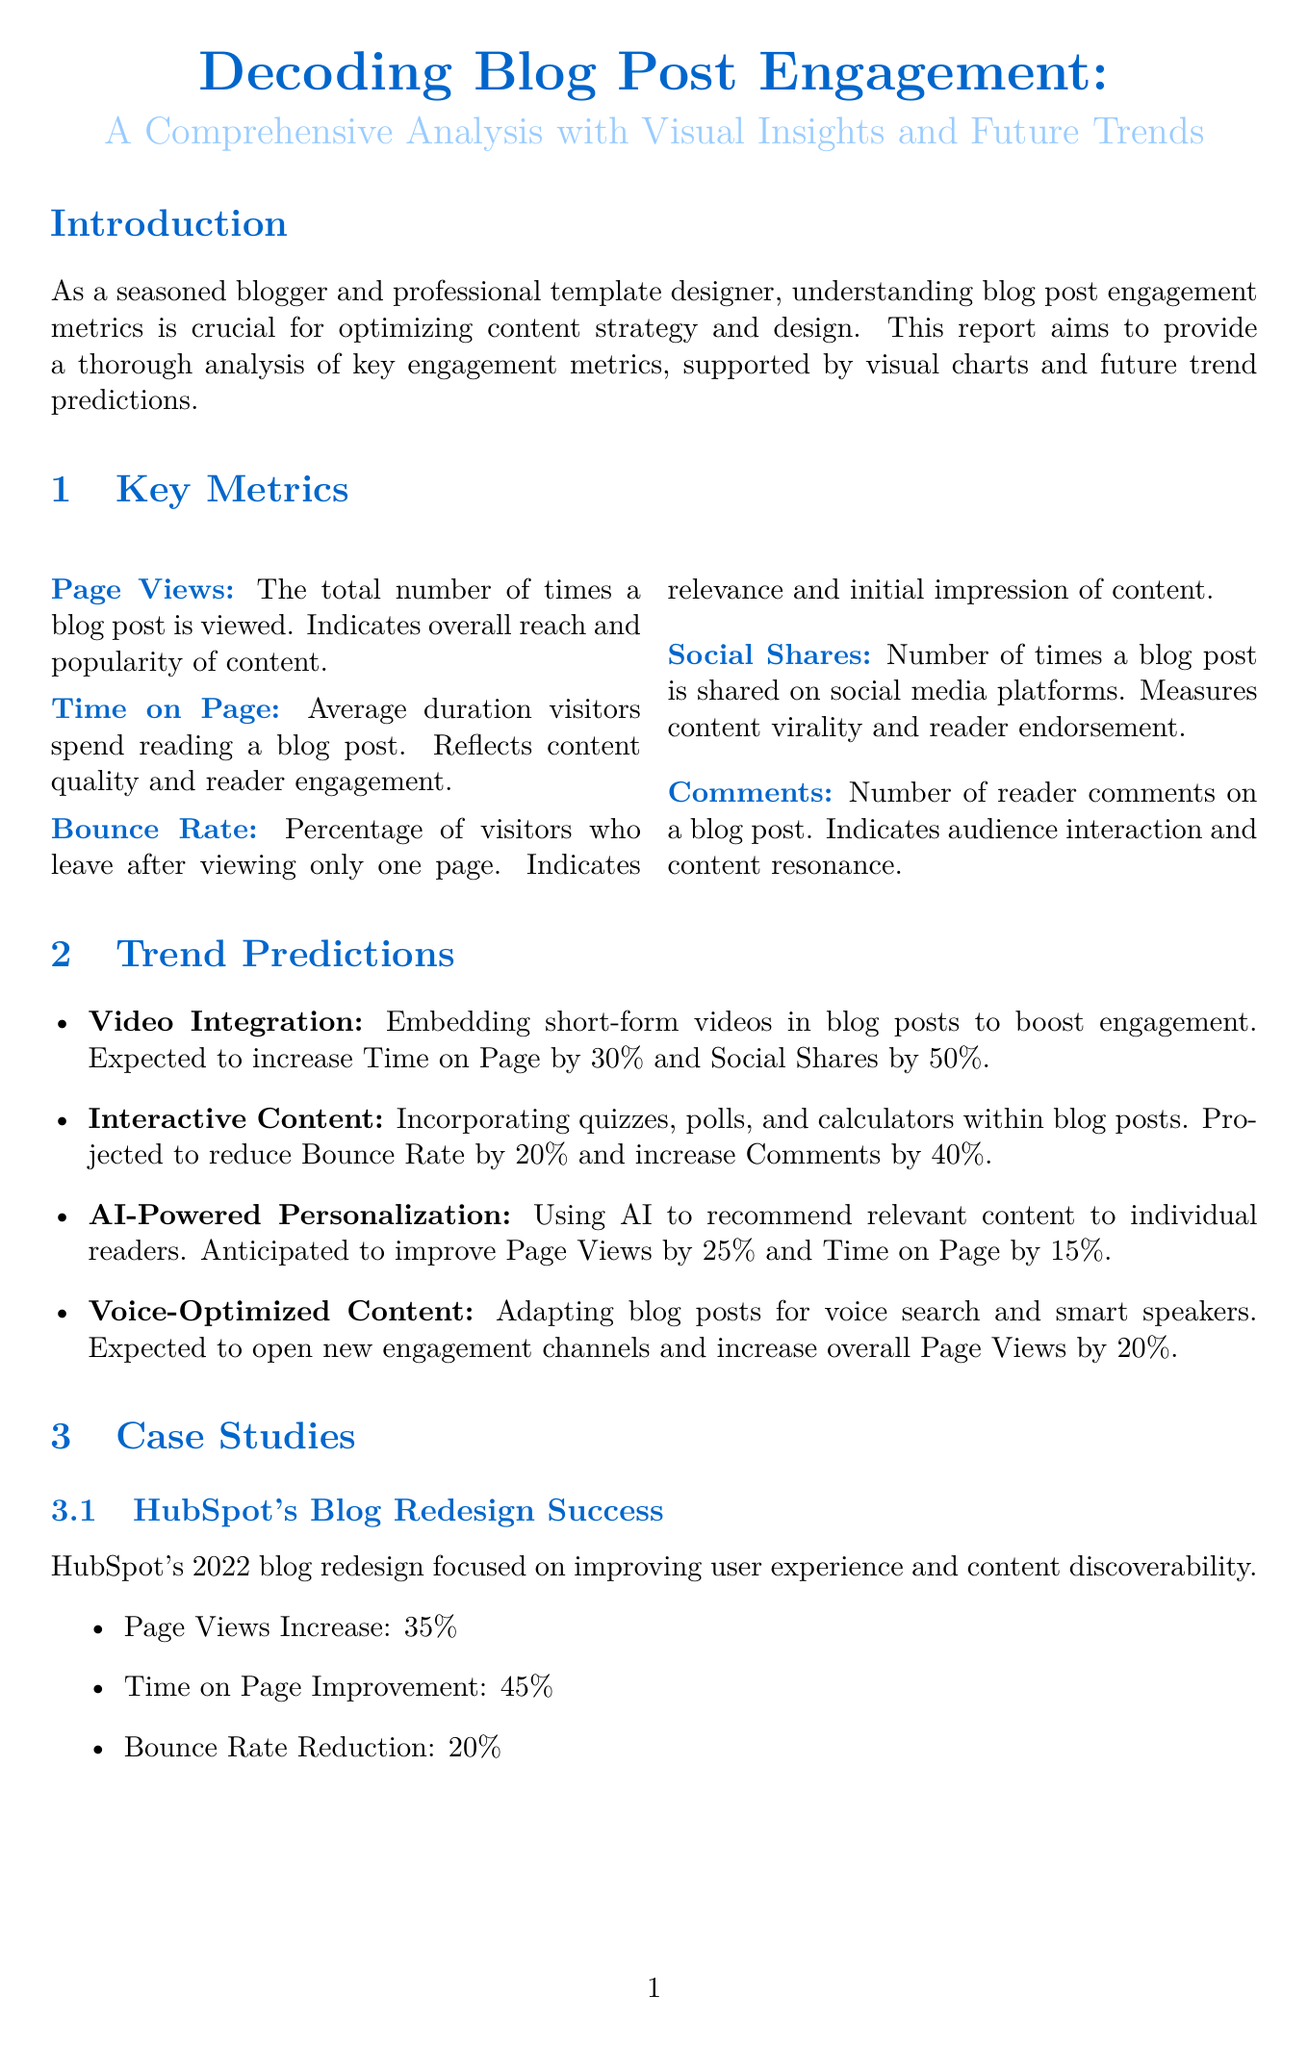What is the title of the report? The title of the report is stated at the beginning as the comprehensive analysis on blog engagement metrics.
Answer: Decoding Blog Post Engagement: A Comprehensive Analysis with Visual Insights and Future Trends How many key engagement metrics are discussed? The number of key engagement metrics is mentioned in the metrics section of the document.
Answer: Five What is the expected increase in Time on Page due to video integration? The document outlines the expected impact of video integration on Time on Page.
Answer: 30% Which content type has the highest average Time on Page? The analysis includes a bar chart that indicates the average Time on Page for different content types.
Answer: Case Studies What percentage of social shares come from Facebook? The pie chart illustrates social shares distribution among various platforms, specifying Facebook's share.
Answer: 35% Which case study focused on blog redesign? The document provides summaries of case studies and indicates the specific focus of each one.
Answer: HubSpot's Blog Redesign Success What is projected to reduce Bounce Rate by 20%? The trend predictions section describes initiatives that can affect engagement metrics, including Bounce Rate.
Answer: Interactive Content What is one key action item mentioned in the conclusion? The conclusion section lists various action items for optimizing blog post engagement.
Answer: Regularly analyze and adapt to changing engagement trends What type of chart shows the Monthly Page Views Trend? The visual charts section specifies the type of charts used to present data.
Answer: Line Chart 